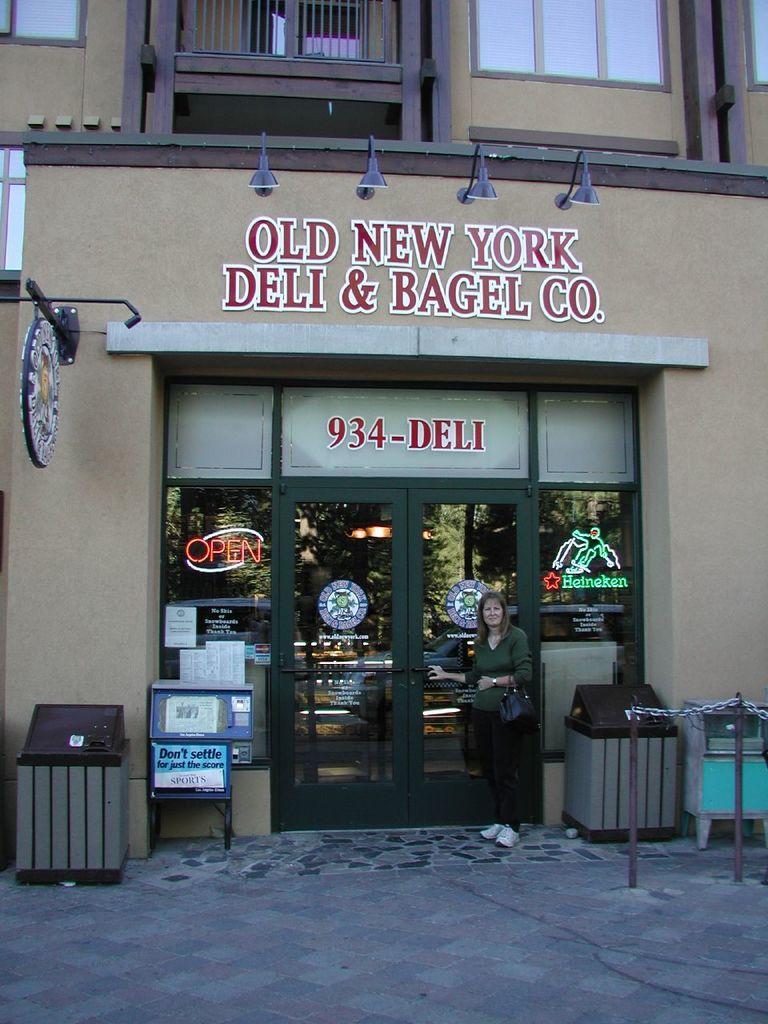Please provide a concise description of this image. In this picture I can see a building. On the wall of a building I can see something written on it and lights attached to the wall. On the right side I can see fence. I can also see some objects, a door and a woman standing beside the door. The woman is holding a bag. 